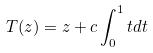Convert formula to latex. <formula><loc_0><loc_0><loc_500><loc_500>T ( z ) = z + c \int _ { 0 } ^ { 1 } t d t</formula> 